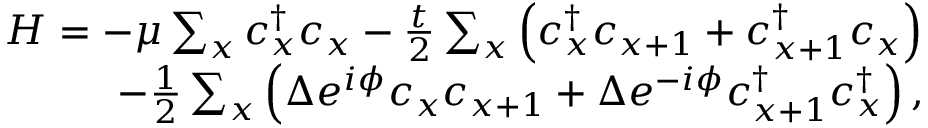<formula> <loc_0><loc_0><loc_500><loc_500>\begin{array} { r } { H = - \mu \sum _ { x } c _ { x } ^ { \dagger } c _ { x } - \frac { t } { 2 } \sum _ { x } \left ( c _ { x } ^ { \dagger } c _ { x + 1 } + c _ { x + 1 } ^ { \dagger } c _ { x } \right ) } \\ { - \frac { 1 } { 2 } \sum _ { x } \left ( \Delta e ^ { i \phi } c _ { x } c _ { x + 1 } + \Delta e ^ { - i \phi } c _ { x + 1 } ^ { \dagger } c _ { x } ^ { \dagger } \right ) , } \end{array}</formula> 